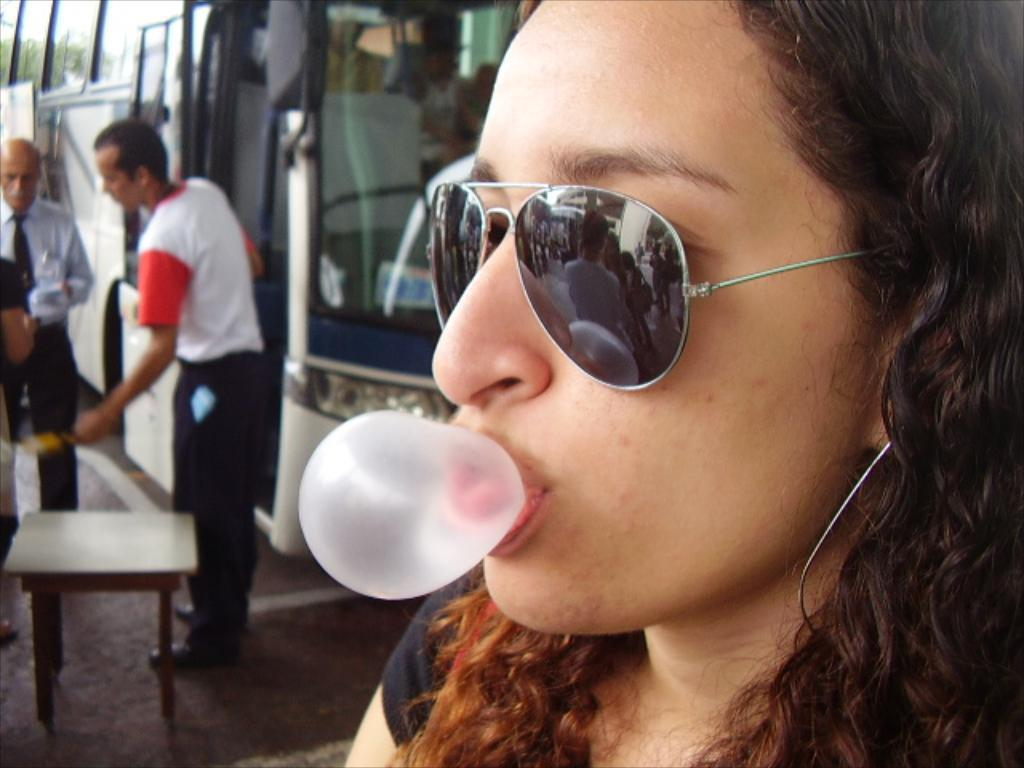Who is present in the image? There is a woman in the image. What is the woman wearing on her face? The woman is wearing goggles. How many people are standing in the image? There are two persons standing in the image. What is the purpose of the table in the image? The table's purpose is not specified, but it is present in the image. What type of object can be seen in the image that is used for transportation? There is a vehicle in the image. What type of animal is biting the woman's leg in the image? There is no animal present in the image, let alone one biting the woman's leg. What type of rail is visible in the image? There is no rail present in the image. 